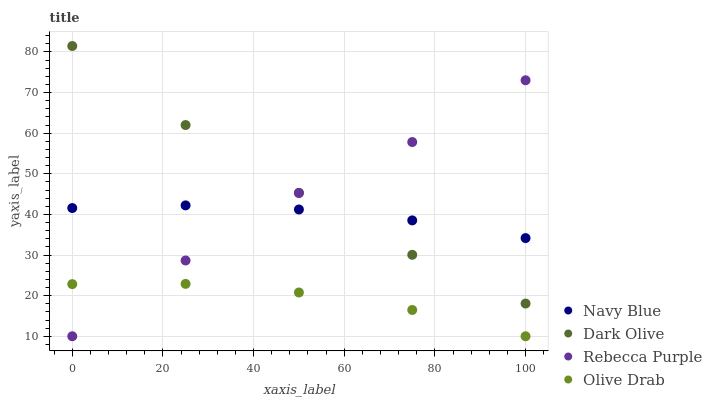Does Olive Drab have the minimum area under the curve?
Answer yes or no. Yes. Does Dark Olive have the maximum area under the curve?
Answer yes or no. Yes. Does Rebecca Purple have the minimum area under the curve?
Answer yes or no. No. Does Rebecca Purple have the maximum area under the curve?
Answer yes or no. No. Is Navy Blue the smoothest?
Answer yes or no. Yes. Is Rebecca Purple the roughest?
Answer yes or no. Yes. Is Dark Olive the smoothest?
Answer yes or no. No. Is Dark Olive the roughest?
Answer yes or no. No. Does Rebecca Purple have the lowest value?
Answer yes or no. Yes. Does Dark Olive have the lowest value?
Answer yes or no. No. Does Dark Olive have the highest value?
Answer yes or no. Yes. Does Rebecca Purple have the highest value?
Answer yes or no. No. Is Olive Drab less than Dark Olive?
Answer yes or no. Yes. Is Navy Blue greater than Olive Drab?
Answer yes or no. Yes. Does Olive Drab intersect Rebecca Purple?
Answer yes or no. Yes. Is Olive Drab less than Rebecca Purple?
Answer yes or no. No. Is Olive Drab greater than Rebecca Purple?
Answer yes or no. No. Does Olive Drab intersect Dark Olive?
Answer yes or no. No. 